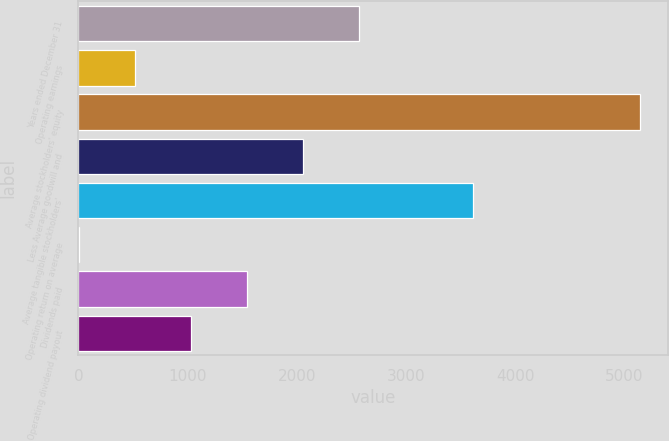Convert chart. <chart><loc_0><loc_0><loc_500><loc_500><bar_chart><fcel>Years ended December 31<fcel>Operating earnings<fcel>Average stockholders' equity<fcel>Less Average goodwill and<fcel>Average tangible stockholders'<fcel>Operating return on average<fcel>Dividends paid<fcel>Operating dividend payout<nl><fcel>2571.95<fcel>516.71<fcel>5141<fcel>2058.14<fcel>3615<fcel>2.9<fcel>1544.33<fcel>1030.52<nl></chart> 